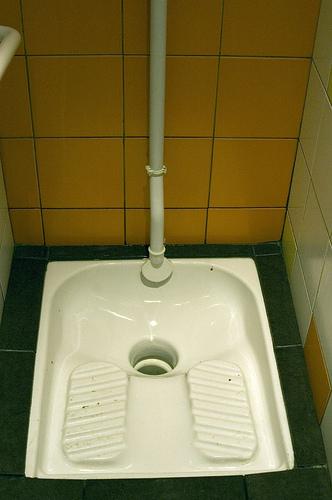Is this an American style toilet?
Answer briefly. No. What color is the tile on the bottom?
Write a very short answer. Black. Are the walls of tiles?
Short answer required. Yes. 